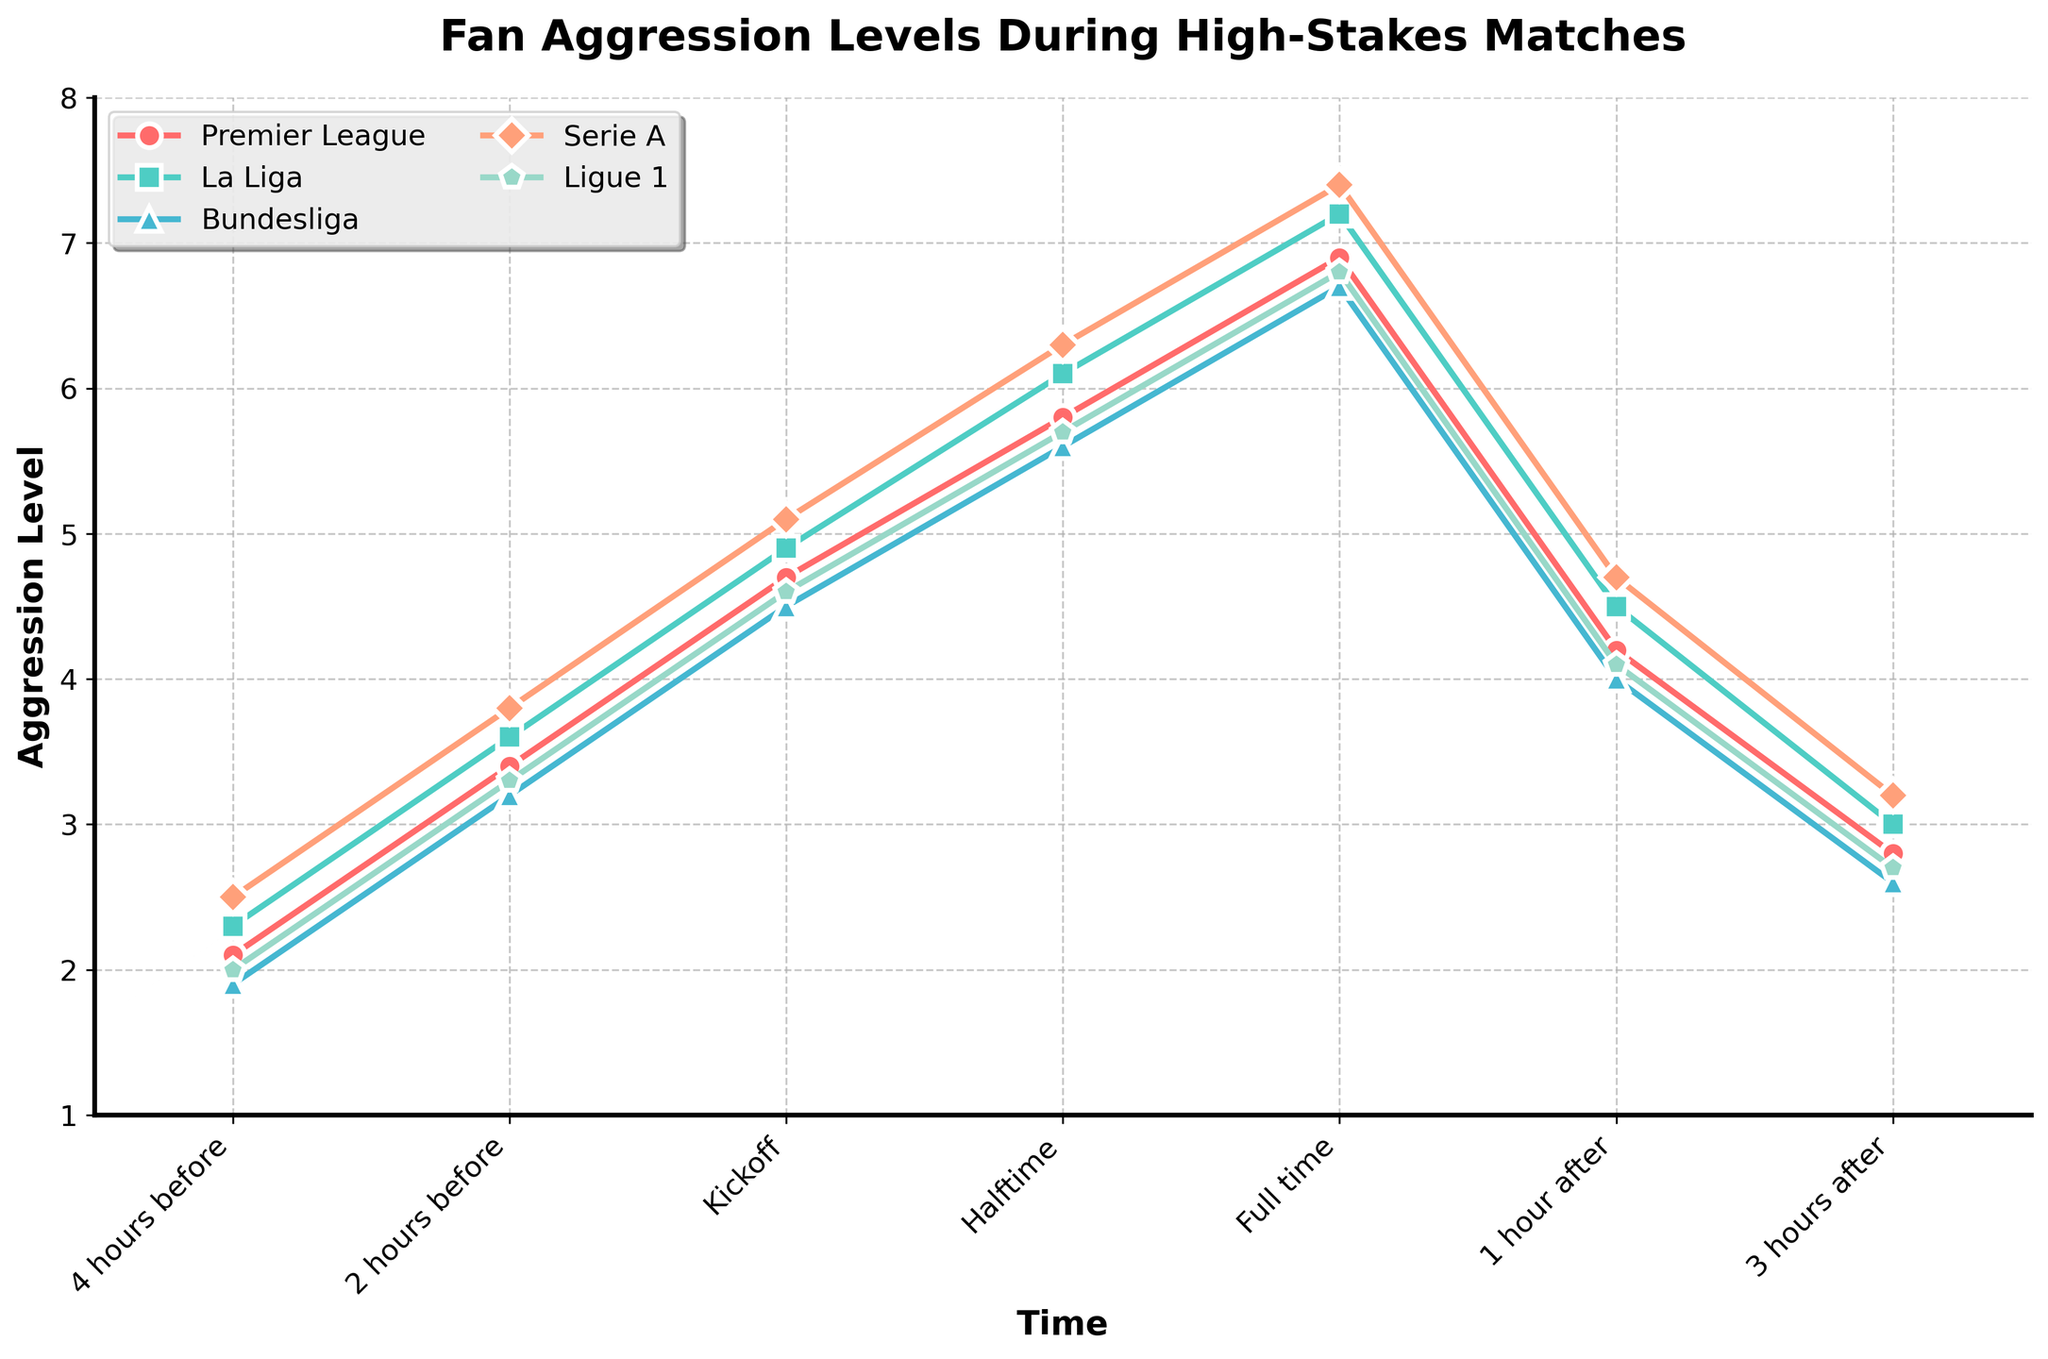How does fan aggression in Premier League compare between halftime and full-time? At halftime, the fan aggression level in the Premier League is 5.8, and at full-time, it increases to 6.9. The aggression level increases by 1.1 points from halftime to full-time.
Answer: It increases by 1.1 points Which league shows the highest peak in fan aggression levels during the game? At full-time, Serie A shows the highest peak in fan aggression levels with a value of 7.4.
Answer: Serie A What is the drop in aggression level for La Liga fans from full-time to 3 hours after the match? At full-time, the aggression level for La Liga fans is 7.2. Three hours after the match, the level drops to 3.0. The drop is 7.2 - 3.0 = 4.2 points.
Answer: 4.2 points What league has the lowest fan aggression level 1 hour after the match? At 1 hour after the match, the Bundesliga fans have the lowest aggression level at 4.0.
Answer: Bundesliga What is the average aggression level 2 hours before the match across all leagues? The levels 2 hours before the match are: Premier League (3.4), La Liga (3.6), Bundesliga (3.2), Serie A (3.8), and Ligue 1 (3.3). Their average is (3.4 + 3.6 + 3.2 + 3.8 + 3.3) / 5 = 3.46.
Answer: 3.46 How does the trend in aggression levels change for Ligue 1 fans from 4 hours before the match to full time? For Ligue 1 fans, aggression levels change as follows: 4 hours before (2.0), 2 hours before (3.3), kickoff (4.6), halftime (5.7), full time (6.8). The trend shows a consistent increase in aggression.
Answer: Consistent increase Which point in time shows the lowest average fan aggression level across all leagues? The aggression levels 4 hours before are the lowest: Premier League (2.1), La Liga (2.3), Bundesliga (1.9), Serie A (2.5), Ligue 1 (2.0). Their average is (2.1 + 2.3 + 1.9 + 2.5 + 2.0) / 5 = 2.16.
Answer: 4 hours before Does Bundesliga or Serie A exhibit more variation in aggression levels from 4 hours before to full time? The change for Bundesliga is from 1.9 to 6.7, a difference of 4.8. For Serie A, it is from 2.5 to 7.4, a difference of 4.9. Serie A exhibits slightly more variation.
Answer: Serie A 